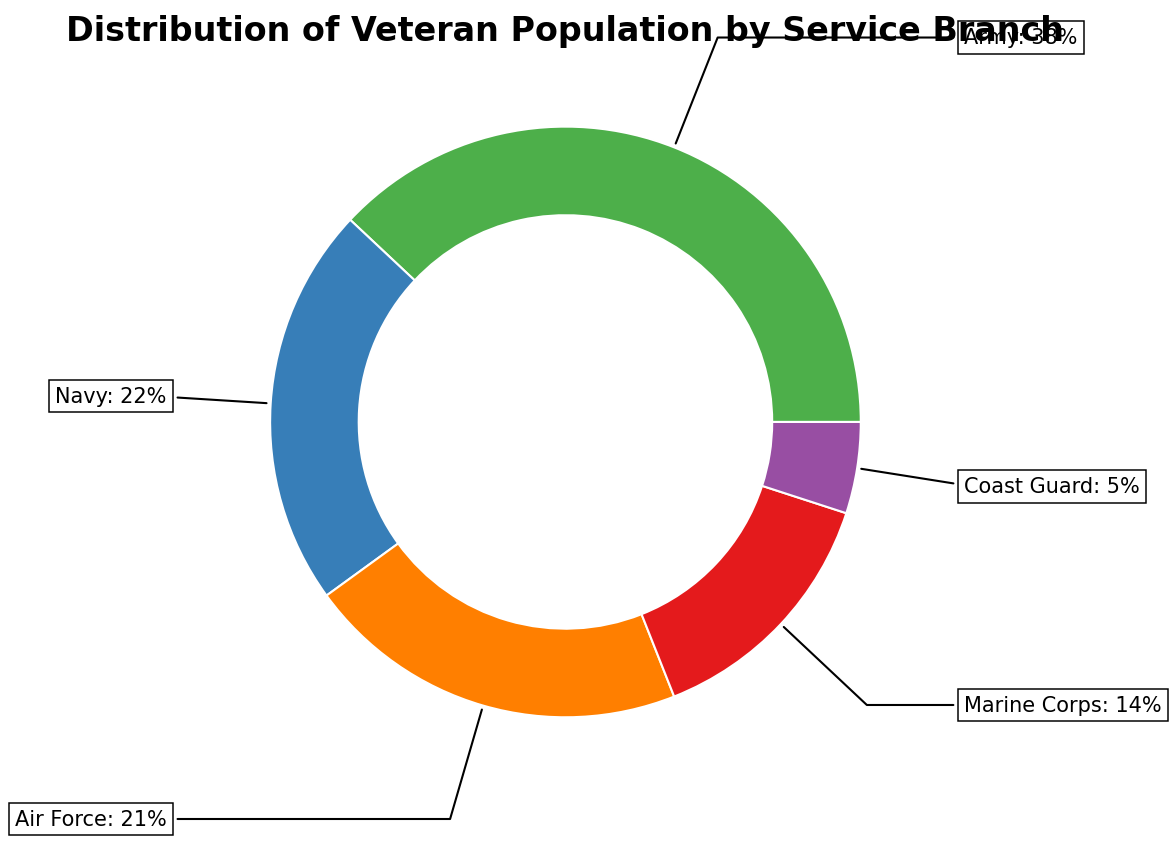what percentage of veterans served in the Army and the Air Force combined? First, note the percentages for the Army and Air Force from the figure: 38% (Army) and 21% (Air Force). Add these two percentages together: 38% + 21% = 59%.
Answer: 59% Which service branch has the smallest percentage of veterans? From the figure, the branch with the smallest percentage of veterans is the Coast Guard with 5%.
Answer: Coast Guard What is the difference in percentage between Navy and Marine Corps veterans? Identify the percentages for the Navy (22%) and the Marine Corps (14%). Subtract the Marine Corps percentage from the Navy percentage: 22% - 14% = 8%.
Answer: 8% Among the Army, Navy, and Air Force, which has the highest veteran population? Check the percentages for the Army (38%), Navy (22%), and Air Force (21%). The Army has the highest percentage at 38%.
Answer: Army By how much does the Army's veteran population percentage exceed the combined percentage of the Marine Corps and Coast Guard? Calculate the combined percentage of the Marine Corps (14%) and Coast Guard (5%), which is 14% + 5% = 19%. Now, subtract this from the Army's percentage: 38% - 19% = 19%.
Answer: 19% 